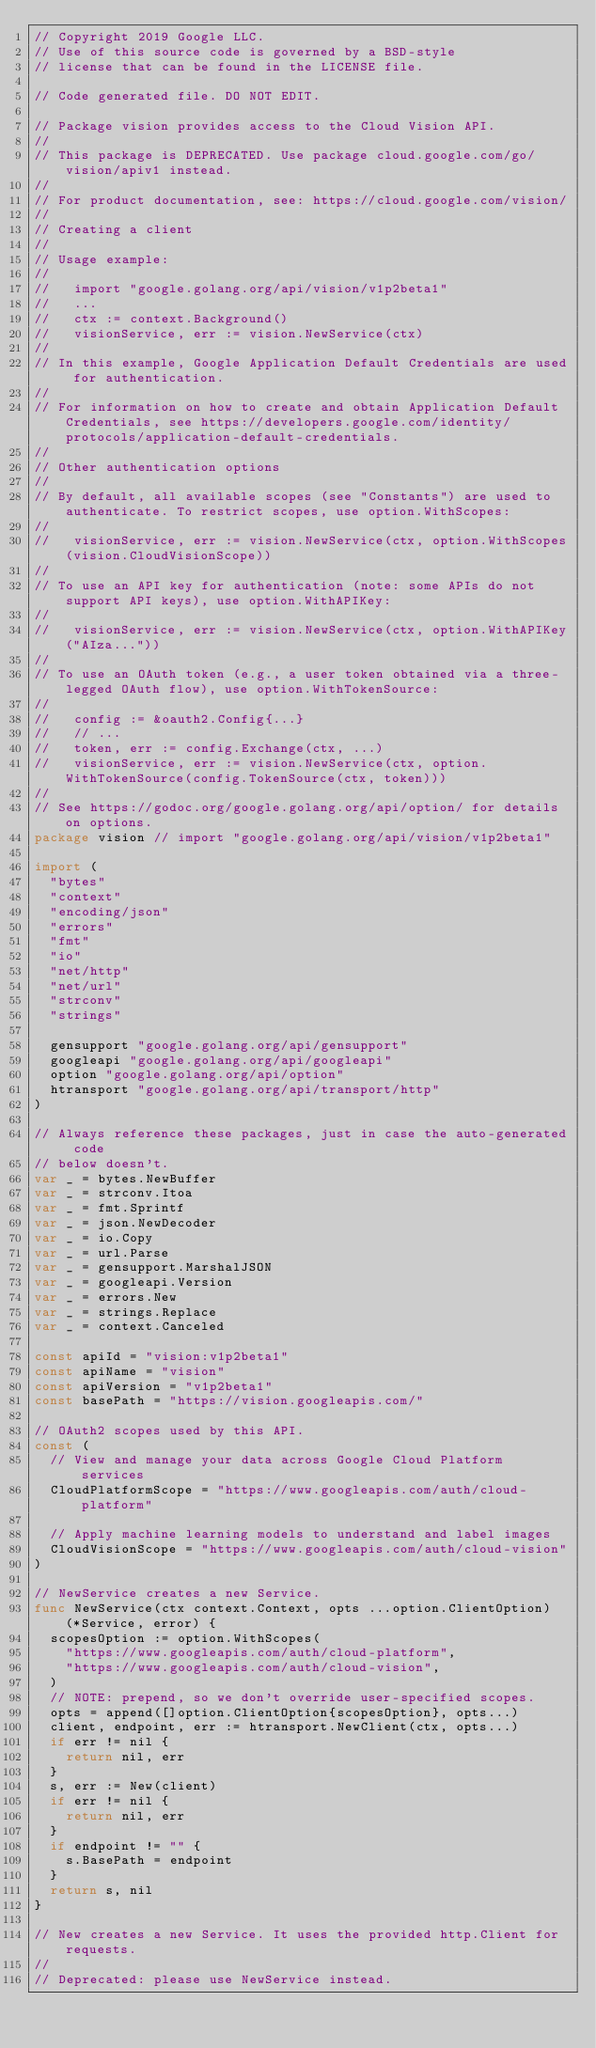<code> <loc_0><loc_0><loc_500><loc_500><_Go_>// Copyright 2019 Google LLC.
// Use of this source code is governed by a BSD-style
// license that can be found in the LICENSE file.

// Code generated file. DO NOT EDIT.

// Package vision provides access to the Cloud Vision API.
//
// This package is DEPRECATED. Use package cloud.google.com/go/vision/apiv1 instead.
//
// For product documentation, see: https://cloud.google.com/vision/
//
// Creating a client
//
// Usage example:
//
//   import "google.golang.org/api/vision/v1p2beta1"
//   ...
//   ctx := context.Background()
//   visionService, err := vision.NewService(ctx)
//
// In this example, Google Application Default Credentials are used for authentication.
//
// For information on how to create and obtain Application Default Credentials, see https://developers.google.com/identity/protocols/application-default-credentials.
//
// Other authentication options
//
// By default, all available scopes (see "Constants") are used to authenticate. To restrict scopes, use option.WithScopes:
//
//   visionService, err := vision.NewService(ctx, option.WithScopes(vision.CloudVisionScope))
//
// To use an API key for authentication (note: some APIs do not support API keys), use option.WithAPIKey:
//
//   visionService, err := vision.NewService(ctx, option.WithAPIKey("AIza..."))
//
// To use an OAuth token (e.g., a user token obtained via a three-legged OAuth flow), use option.WithTokenSource:
//
//   config := &oauth2.Config{...}
//   // ...
//   token, err := config.Exchange(ctx, ...)
//   visionService, err := vision.NewService(ctx, option.WithTokenSource(config.TokenSource(ctx, token)))
//
// See https://godoc.org/google.golang.org/api/option/ for details on options.
package vision // import "google.golang.org/api/vision/v1p2beta1"

import (
	"bytes"
	"context"
	"encoding/json"
	"errors"
	"fmt"
	"io"
	"net/http"
	"net/url"
	"strconv"
	"strings"

	gensupport "google.golang.org/api/gensupport"
	googleapi "google.golang.org/api/googleapi"
	option "google.golang.org/api/option"
	htransport "google.golang.org/api/transport/http"
)

// Always reference these packages, just in case the auto-generated code
// below doesn't.
var _ = bytes.NewBuffer
var _ = strconv.Itoa
var _ = fmt.Sprintf
var _ = json.NewDecoder
var _ = io.Copy
var _ = url.Parse
var _ = gensupport.MarshalJSON
var _ = googleapi.Version
var _ = errors.New
var _ = strings.Replace
var _ = context.Canceled

const apiId = "vision:v1p2beta1"
const apiName = "vision"
const apiVersion = "v1p2beta1"
const basePath = "https://vision.googleapis.com/"

// OAuth2 scopes used by this API.
const (
	// View and manage your data across Google Cloud Platform services
	CloudPlatformScope = "https://www.googleapis.com/auth/cloud-platform"

	// Apply machine learning models to understand and label images
	CloudVisionScope = "https://www.googleapis.com/auth/cloud-vision"
)

// NewService creates a new Service.
func NewService(ctx context.Context, opts ...option.ClientOption) (*Service, error) {
	scopesOption := option.WithScopes(
		"https://www.googleapis.com/auth/cloud-platform",
		"https://www.googleapis.com/auth/cloud-vision",
	)
	// NOTE: prepend, so we don't override user-specified scopes.
	opts = append([]option.ClientOption{scopesOption}, opts...)
	client, endpoint, err := htransport.NewClient(ctx, opts...)
	if err != nil {
		return nil, err
	}
	s, err := New(client)
	if err != nil {
		return nil, err
	}
	if endpoint != "" {
		s.BasePath = endpoint
	}
	return s, nil
}

// New creates a new Service. It uses the provided http.Client for requests.
//
// Deprecated: please use NewService instead.</code> 